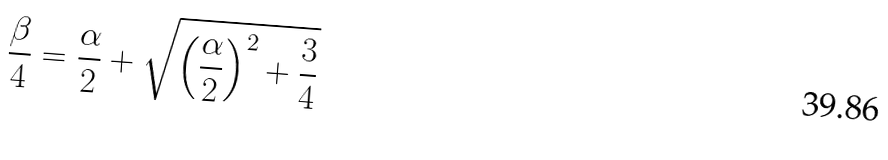<formula> <loc_0><loc_0><loc_500><loc_500>\frac { \beta } { 4 } = \frac { \alpha } { 2 } + \sqrt { \left ( \frac { \alpha } { 2 } \right ) ^ { 2 } + \frac { 3 } { 4 } }</formula> 